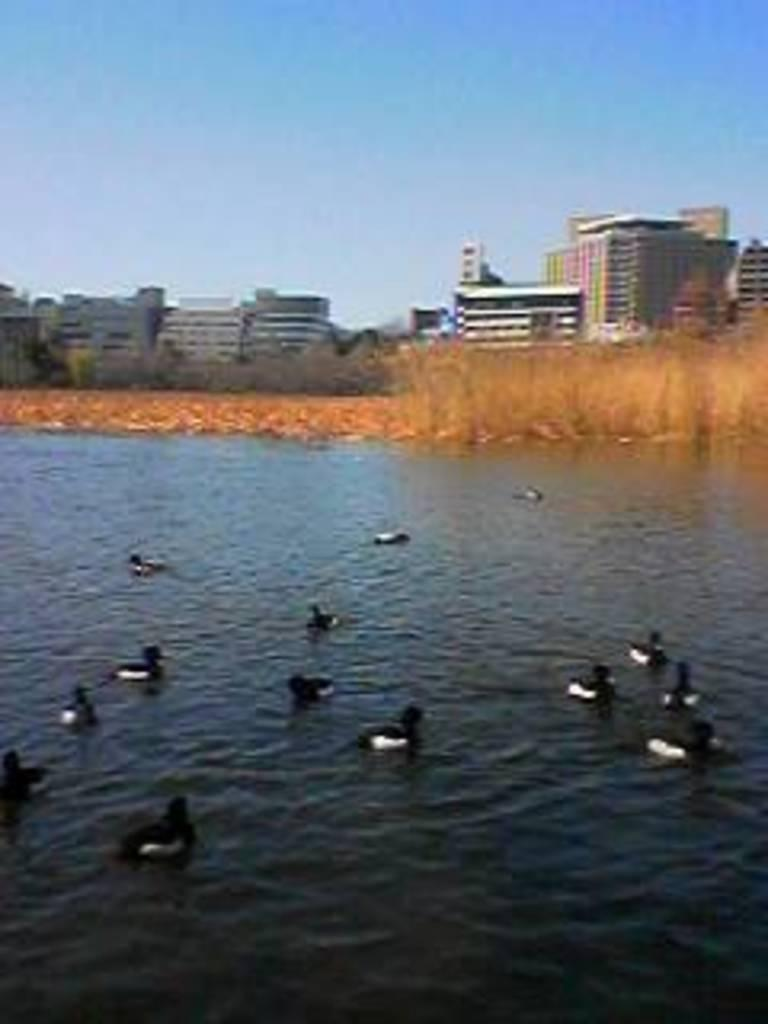What type of animals can be seen in the image? There are ducks in the water. What can be seen in the background of the image? There is grass and buildings in the background of the image. What is visible at the top of the image? The sky is visible at the top of the image. Can you see a quiver in the image? There is no quiver present in the image. Are the ducks swimming in the image? While it can be inferred that the ducks are likely swimming in the water, the image does not explicitly show them swimming. 